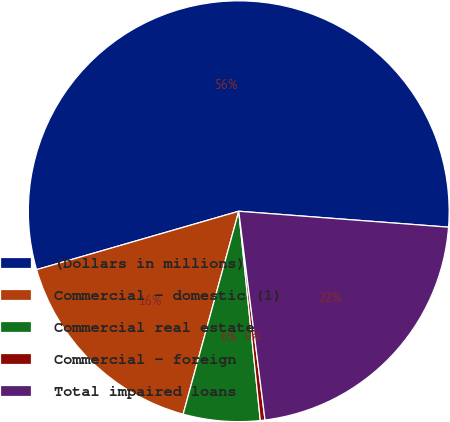Convert chart to OTSL. <chart><loc_0><loc_0><loc_500><loc_500><pie_chart><fcel>(Dollars in millions)<fcel>Commercial - domestic (1)<fcel>Commercial real estate<fcel>Commercial - foreign<fcel>Total impaired loans<nl><fcel>55.68%<fcel>16.27%<fcel>5.89%<fcel>0.36%<fcel>21.8%<nl></chart> 